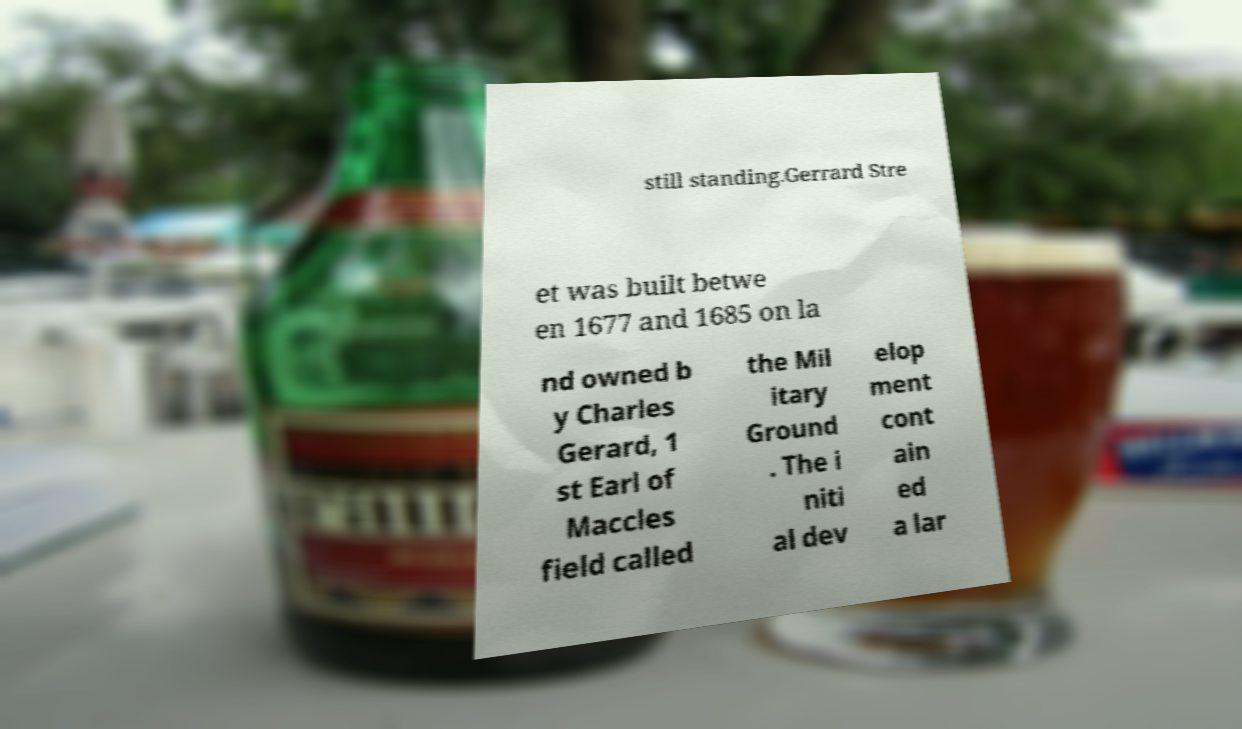For documentation purposes, I need the text within this image transcribed. Could you provide that? still standing.Gerrard Stre et was built betwe en 1677 and 1685 on la nd owned b y Charles Gerard, 1 st Earl of Maccles field called the Mil itary Ground . The i niti al dev elop ment cont ain ed a lar 